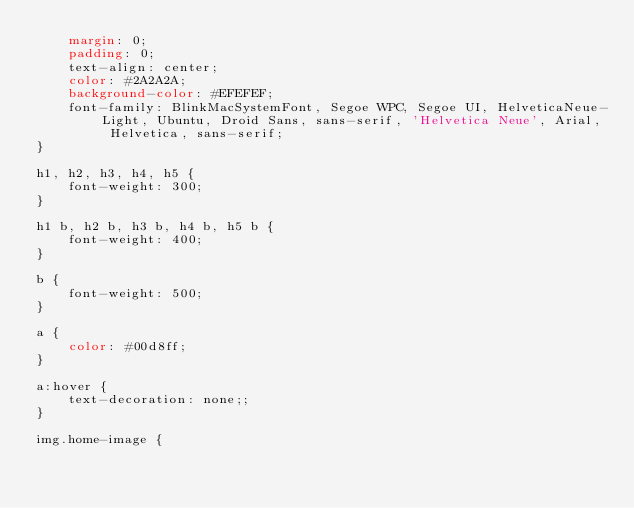<code> <loc_0><loc_0><loc_500><loc_500><_CSS_>    margin: 0;
    padding: 0;
    text-align: center;
    color: #2A2A2A;
    background-color: #EFEFEF;
    font-family: BlinkMacSystemFont, Segoe WPC, Segoe UI, HelveticaNeue-Light, Ubuntu, Droid Sans, sans-serif, 'Helvetica Neue', Arial, Helvetica, sans-serif;
}

h1, h2, h3, h4, h5 {
    font-weight: 300;
}

h1 b, h2 b, h3 b, h4 b, h5 b {
    font-weight: 400;
}

b {
    font-weight: 500;
}

a {
    color: #00d8ff;
}

a:hover {
    text-decoration: none;;
}

img.home-image {</code> 